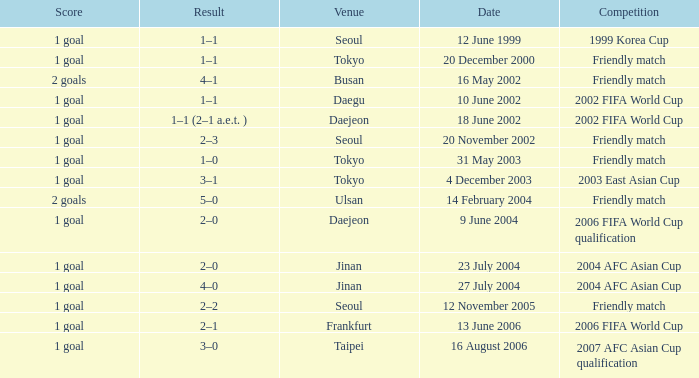On november 20, 2002, where did the game occur? Seoul. 